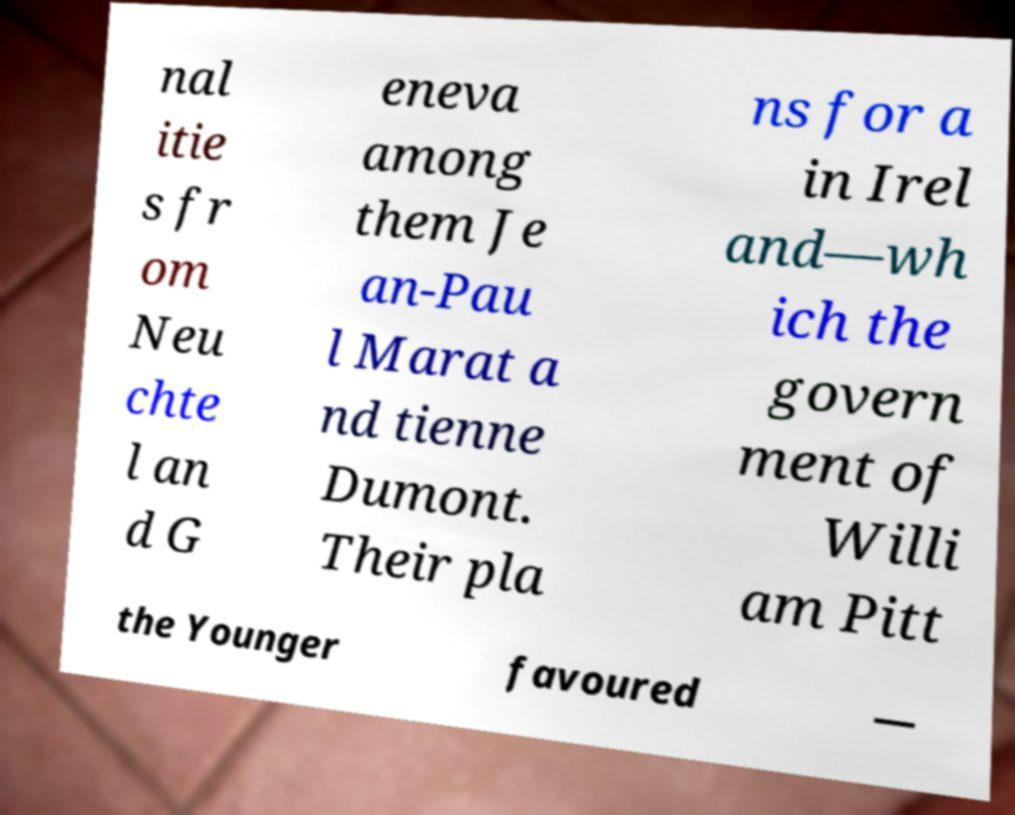For documentation purposes, I need the text within this image transcribed. Could you provide that? nal itie s fr om Neu chte l an d G eneva among them Je an-Pau l Marat a nd tienne Dumont. Their pla ns for a in Irel and—wh ich the govern ment of Willi am Pitt the Younger favoured — 